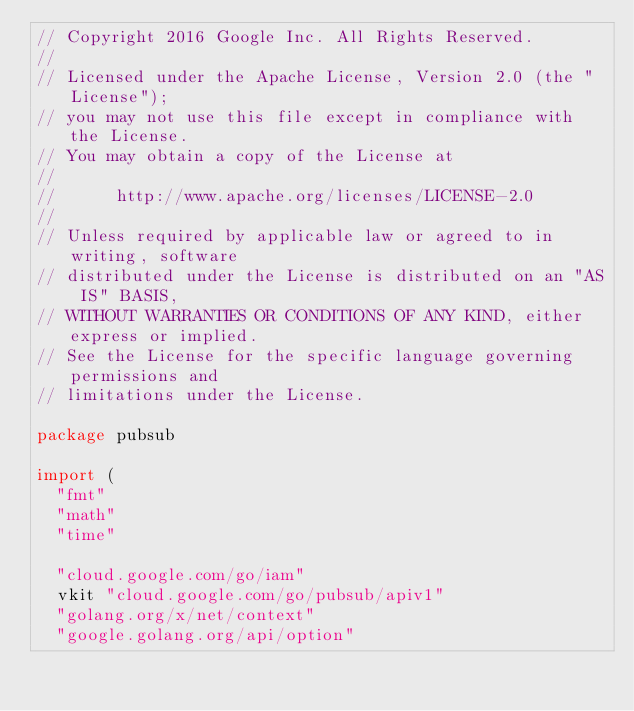<code> <loc_0><loc_0><loc_500><loc_500><_Go_>// Copyright 2016 Google Inc. All Rights Reserved.
//
// Licensed under the Apache License, Version 2.0 (the "License");
// you may not use this file except in compliance with the License.
// You may obtain a copy of the License at
//
//      http://www.apache.org/licenses/LICENSE-2.0
//
// Unless required by applicable law or agreed to in writing, software
// distributed under the License is distributed on an "AS IS" BASIS,
// WITHOUT WARRANTIES OR CONDITIONS OF ANY KIND, either express or implied.
// See the License for the specific language governing permissions and
// limitations under the License.

package pubsub

import (
	"fmt"
	"math"
	"time"

	"cloud.google.com/go/iam"
	vkit "cloud.google.com/go/pubsub/apiv1"
	"golang.org/x/net/context"
	"google.golang.org/api/option"</code> 